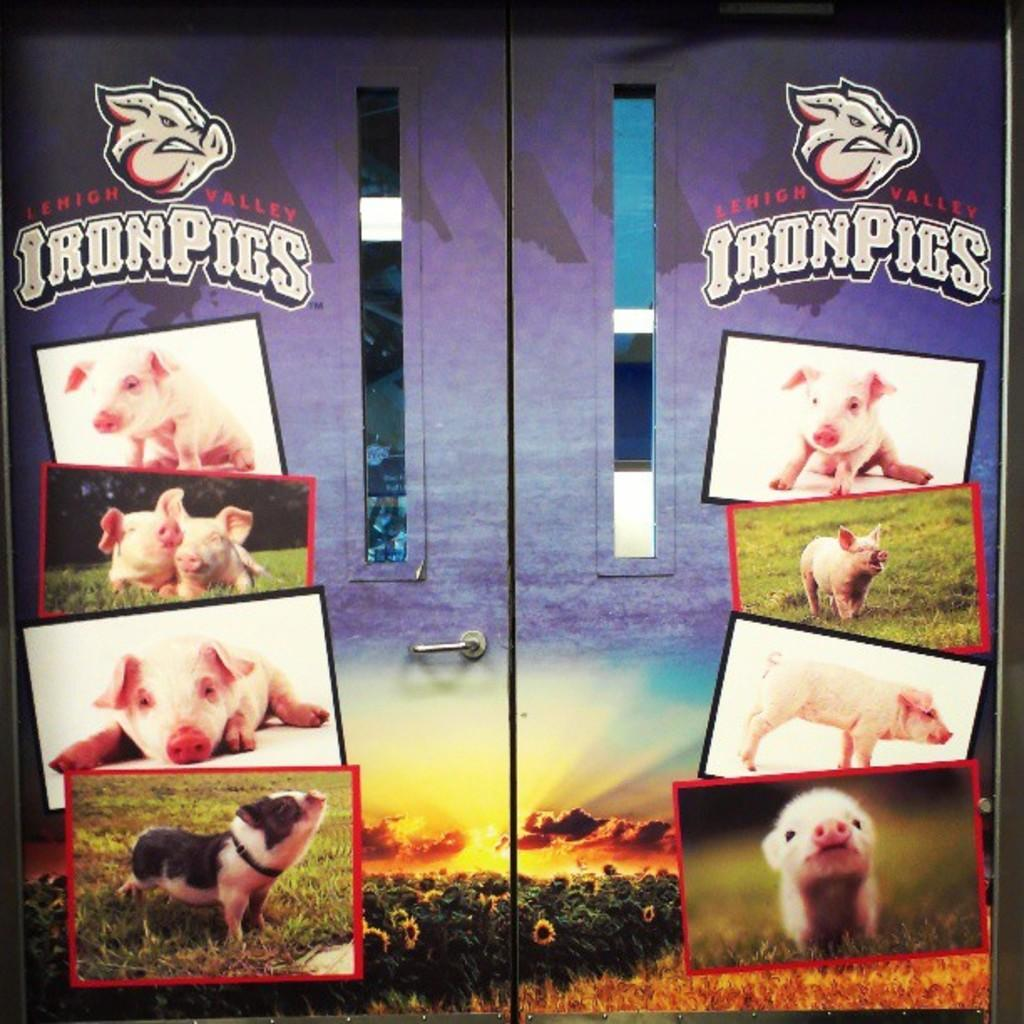What is the main object in the image? There is a board of a cupboard with a handle in the image. What is depicted on the cupboard? There are pictures of a pig on the cupboard. What type of lace can be seen hanging from the handle of the cupboard in the image? There is no lace present on the handle of the cupboard in the image. What kind of club is associated with the pig in the image? There is no club or any indication of a club in the image; it only features pictures of a pig on the cupboard. 